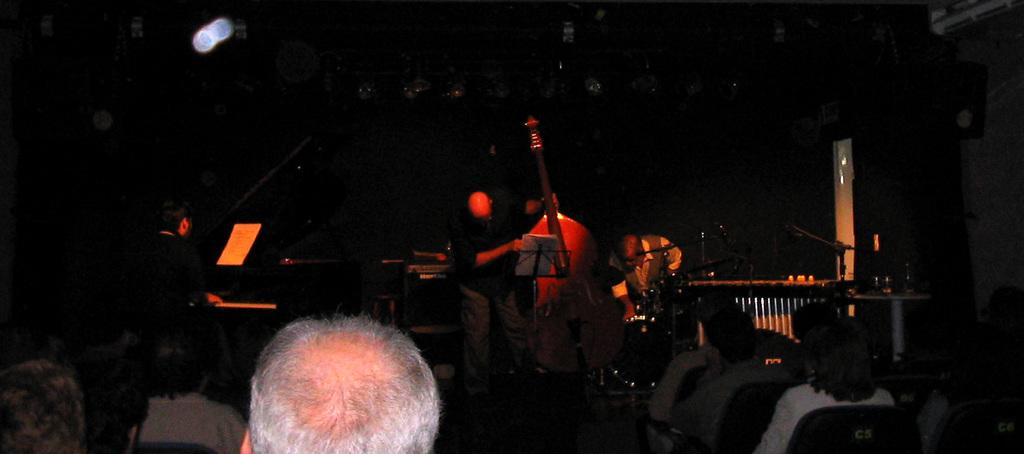What are the people in the front of the image doing? The people in the front of the image are sitting on chairs. Can you describe the man in the background of the image? The man in the background of the image is standing and holding a big violin. What is the color of the background in the image? The background of the image is dark. How many chairs are there in the garden? There is no mention of a garden in the image, and therefore no chairs in the garden. 